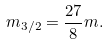Convert formula to latex. <formula><loc_0><loc_0><loc_500><loc_500>m _ { 3 / 2 } = \frac { 2 7 } { 8 } m .</formula> 